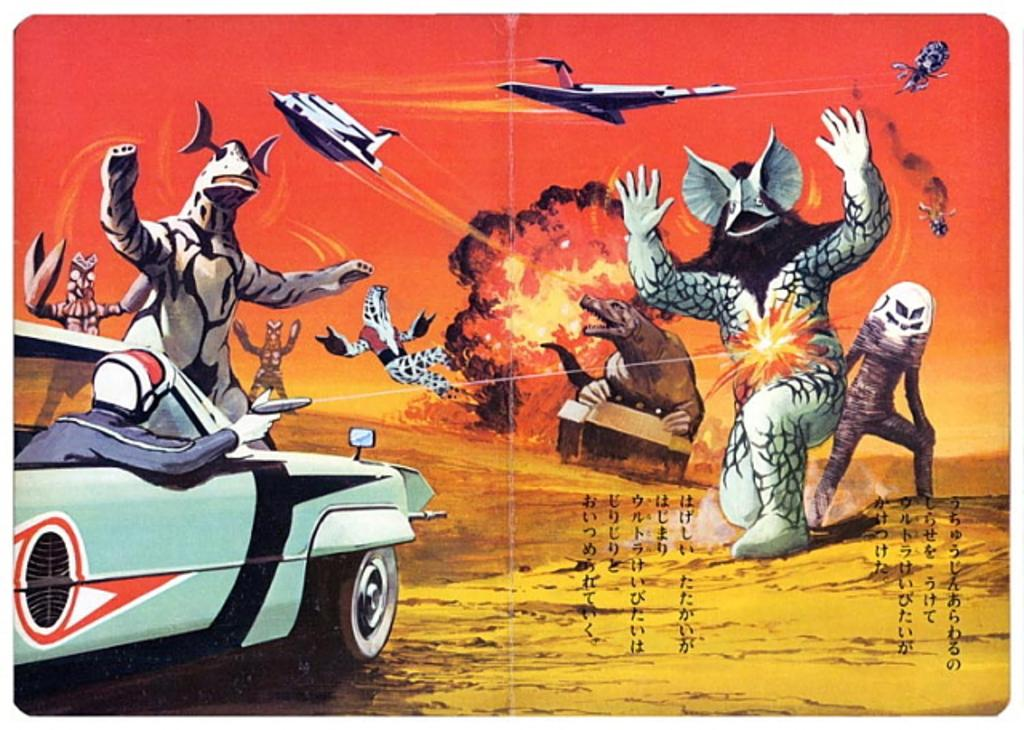What type of image is being described? The image is animated. What vehicle is present in the image? There is a car in the image. Who or what is inside the car? There is a person in the car. Are there any living creatures besides the person in the image? Yes, there are animals in the image. What type of bone can be seen in the image? There is no bone present in the image. What route is the car taking in the image? The image is static, so there is no route being taken by the car. 